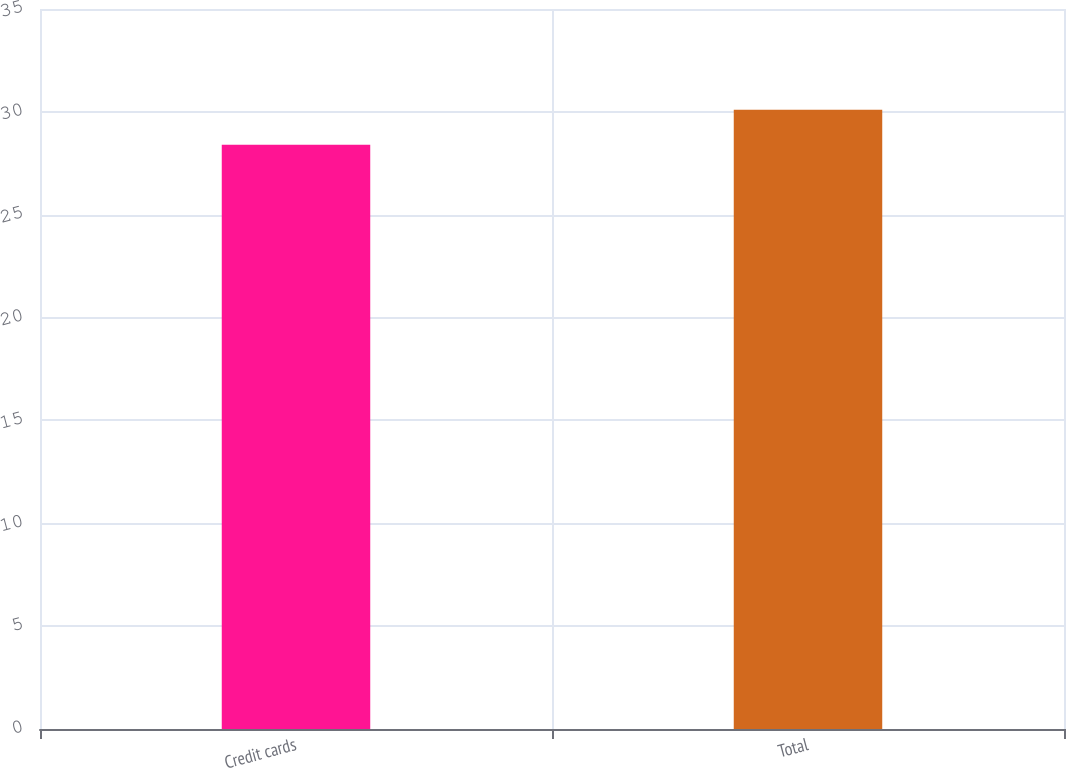<chart> <loc_0><loc_0><loc_500><loc_500><bar_chart><fcel>Credit cards<fcel>Total<nl><fcel>28.4<fcel>30.1<nl></chart> 